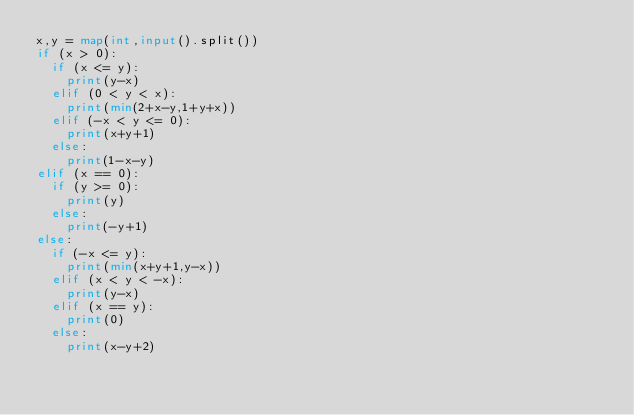Convert code to text. <code><loc_0><loc_0><loc_500><loc_500><_Python_>x,y = map(int,input().split())
if (x > 0):
  if (x <= y):
    print(y-x)
  elif (0 < y < x):
    print(min(2+x-y,1+y+x))
  elif (-x < y <= 0):
    print(x+y+1)
  else:
    print(1-x-y)
elif (x == 0):
  if (y >= 0):
    print(y)
  else:
    print(-y+1)
else:
  if (-x <= y):
    print(min(x+y+1,y-x))
  elif (x < y < -x):
    print(y-x)
  elif (x == y):
    print(0)
  else:
    print(x-y+2)</code> 